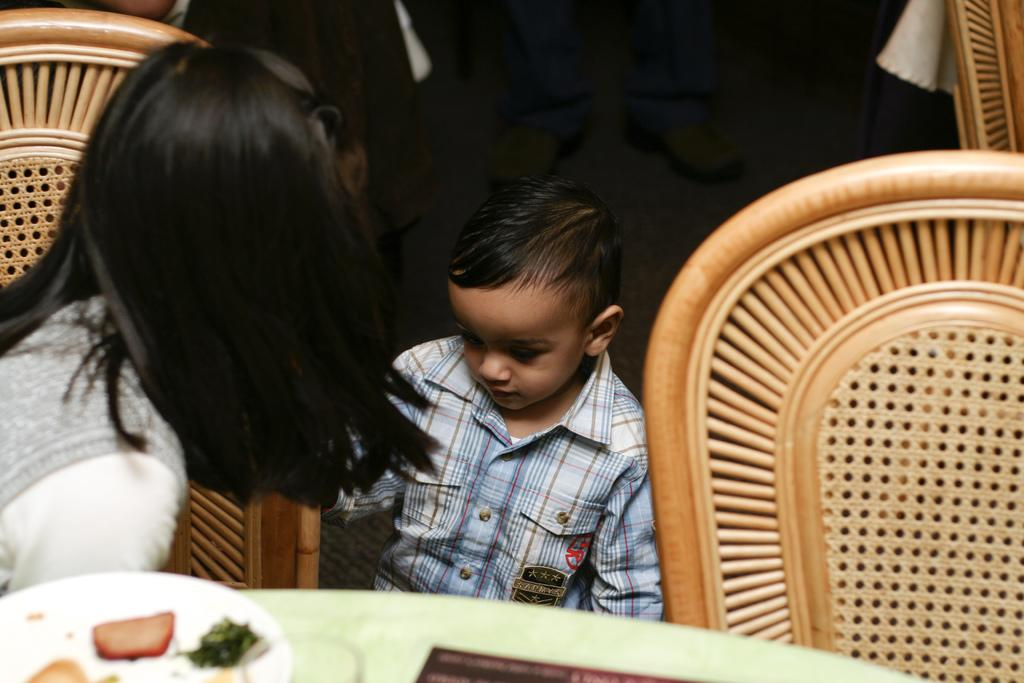What is the woman doing in the image? The woman is seated on a chair in the image. Who is with the woman in the image? There is a boy next to the woman in the image. What can be seen on the table in front of the woman and the boy? There are food items on a table in front of the woman and the boy. What type of plastic material is being used by the woman to say good-bye in the image? There is no plastic material or action of saying good-bye present in the image. 